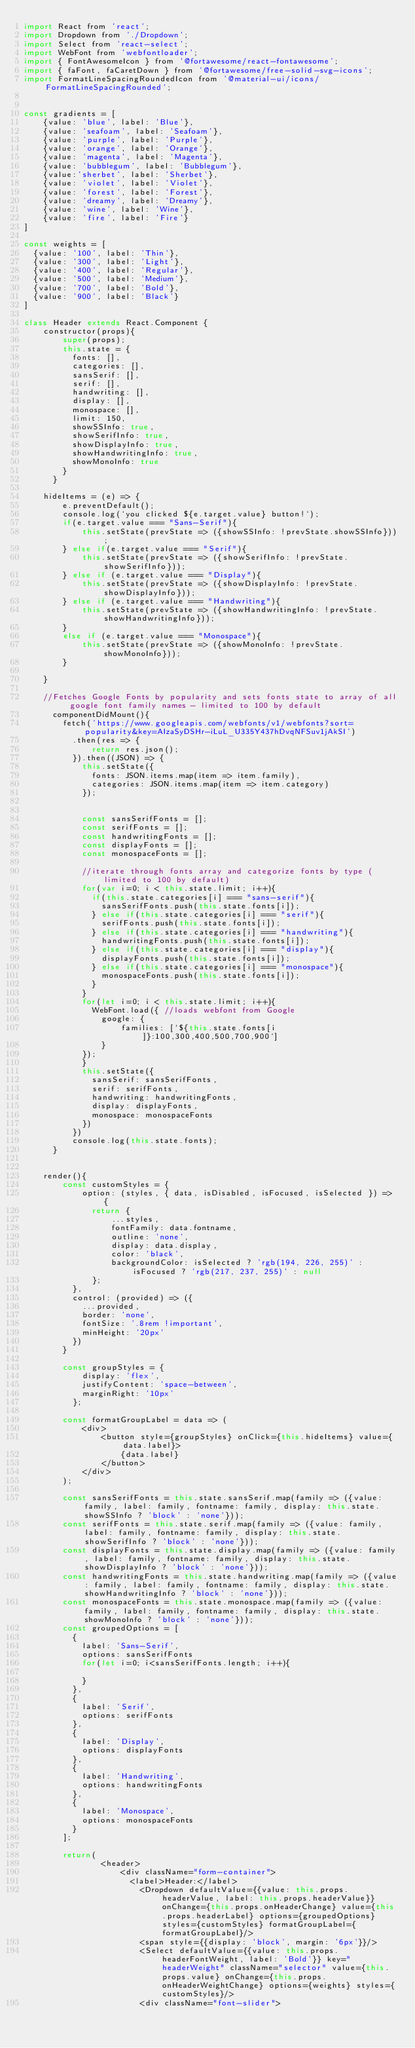Convert code to text. <code><loc_0><loc_0><loc_500><loc_500><_JavaScript_>import React from 'react';
import Dropdown from './Dropdown';
import Select from 'react-select';
import WebFont from 'webfontloader';
import { FontAwesomeIcon } from '@fortawesome/react-fontawesome';
import { faFont, faCaretDown } from '@fortawesome/free-solid-svg-icons';
import FormatLineSpacingRoundedIcon from '@material-ui/icons/FormatLineSpacingRounded';


const gradients = [
    {value: 'blue', label: 'Blue'}, 
    {value: 'seafoam', label: 'Seafoam'},
    {value: 'purple', label: 'Purple'},
    {value: 'orange', label: 'Orange'},
    {value: 'magenta', label: 'Magenta'},
    {value: 'bubblegum', label: 'Bubblegum'},
    {value:'sherbet', label: 'Sherbet'},
    {value: 'violet', label: 'Violet'},
    {value: 'forest', label: 'Forest'},
    {value: 'dreamy', label: 'Dreamy'},
    {value: 'wine', label: 'Wine'},
    {value: 'fire', label: 'Fire'}
]

const weights = [
  {value: '100', label: 'Thin'},
  {value: '300', label: 'Light'},
  {value: '400', label: 'Regular'},
  {value: '500', label: 'Medium'},
  {value: '700', label: 'Bold'},
  {value: '900', label: 'Black'}
]

class Header extends React.Component {
    constructor(props){
        super(props);
        this.state = {
          fonts: [],
          categories: [],
          sansSerif: [],
          serif: [],
          handwriting: [],
          display: [],
          monospace: [],
          limit: 150,
          showSSInfo: true,
          showSerifInfo: true,
          showDisplayInfo: true,
          showHandwritingInfo: true,
          showMonoInfo: true
        }
      }
      
    hideItems = (e) => {
        e.preventDefault();
        console.log(`you clicked ${e.target.value} button!`);
        if(e.target.value === "Sans-Serif"){
            this.setState(prevState => ({showSSInfo: !prevState.showSSInfo}));
        } else if(e.target.value === "Serif"){
            this.setState(prevState => ({showSerifInfo: !prevState.showSerifInfo}));
        } else if (e.target.value === "Display"){
            this.setState(prevState => ({showDisplayInfo: !prevState.showDisplayInfo}));
        } else if (e.target.value === "Handwriting"){
            this.setState(prevState => ({showHandwritingInfo: !prevState.showHandwritingInfo}));
        }
        else if (e.target.value === "Monospace"){
            this.setState(prevState => ({showMonoInfo: !prevState.showMonoInfo}));
        }
        
    }
    
    //Fetches Google Fonts by popularity and sets fonts state to array of all google font family names - limited to 100 by default
      componentDidMount(){
        fetch('https://www.googleapis.com/webfonts/v1/webfonts?sort=popularity&key=AIzaSyDSHr-iLuL_U335Y437hDvqNFSuv1jAkSI')
          .then(res => {
              return res.json();
          }).then((JSON) => {
            this.setState({
              fonts: JSON.items.map(item => item.family),
              categories: JSON.items.map(item => item.category)
            });
    
            
            const sansSerifFonts = [];
            const serifFonts = [];
            const handwritingFonts = [];
            const displayFonts = [];
            const monospaceFonts = [];
    
            //iterate through fonts array and categorize fonts by type (limited to 100 by default)
            for(var i=0; i < this.state.limit; i++){
              if(this.state.categories[i] === "sans-serif"){
                sansSerifFonts.push(this.state.fonts[i]);
              } else if(this.state.categories[i] === "serif"){
                serifFonts.push(this.state.fonts[i]);
              } else if(this.state.categories[i] === "handwriting"){
                handwritingFonts.push(this.state.fonts[i]);
              } else if(this.state.categories[i] === "display"){
                displayFonts.push(this.state.fonts[i]);
              } else if(this.state.categories[i] === "monospace"){
                monospaceFonts.push(this.state.fonts[i]);
              }
            }
            for(let i=0; i < this.state.limit; i++){
              WebFont.load({ //loads webfont from Google 
                google: {
                    families: [`${this.state.fonts[i]}:100,300,400,500,700,900`]
                }
            });
            }
            this.setState({
              sansSerif: sansSerifFonts,
              serif: serifFonts,
              handwriting: handwritingFonts,
              display: displayFonts,
              monospace: monospaceFonts
            })
          })
          console.log(this.state.fonts);
      }


    render(){
        const customStyles = {
            option: (styles, { data, isDisabled, isFocused, isSelected }) => {
              return {
                  ...styles,
                  fontFamily: data.fontname,
                  outline: 'none',
                  display: data.display,
                  color: 'black',
                  backgroundColor: isSelected ? 'rgb(194, 226, 255)' :isFocused ? 'rgb(217, 237, 255)' : null
              };
          },
          control: (provided) => ({
            ...provided,
            border: 'none',
            fontSize: '.8rem !important',
            minHeight: '20px'
          })
        }

        const groupStyles = {
            display: 'flex',
            justifyContent: 'space-between',
            marginRight: '10px'
          };

        const formatGroupLabel = data => (
            <div>  
                <button style={groupStyles} onClick={this.hideItems} value={data.label}>
                    {data.label}
                </button>
            </div>
        );

        const sansSerifFonts = this.state.sansSerif.map(family => ({value: family, label: family, fontname: family, display: this.state.showSSInfo ? 'block' : 'none'}));
        const serifFonts = this.state.serif.map(family => ({value: family, label: family, fontname: family, display: this.state.showSerifInfo ? 'block' : 'none'}));
        const displayFonts = this.state.display.map(family => ({value: family, label: family, fontname: family, display: this.state.showDisplayInfo ? 'block' : 'none'}));
        const handwritingFonts = this.state.handwriting.map(family => ({value: family, label: family, fontname: family, display: this.state.showHandwritingInfo ? 'block' : 'none'}));
        const monospaceFonts = this.state.monospace.map(family => ({value: family, label: family, fontname: family, display: this.state.showMonoInfo ? 'block' : 'none'}));
        const groupedOptions = [
          {
            label: 'Sans-Serif',
            options: sansSerifFonts
            for(let i=0; i<sansSerifFonts.length; i++){
              
            }
          },
          {
            label: 'Serif',
            options: serifFonts
          },
          {
            label: 'Display',
            options: displayFonts
          },
          {
            label: 'Handwriting',
            options: handwritingFonts
          },
          {
            label: 'Monospace',
            options: monospaceFonts
          }
        ];
        
        return(
                <header>
                    <div className="form-container">
                      <label>Header:</label>
                        <Dropdown defaultValue={{value: this.props.headerValue, label: this.props.headerValue}}  onChange={this.props.onHeaderChange} value={this.props.headerLabel} options={groupedOptions} styles={customStyles} formatGroupLabel={formatGroupLabel}/>
                        <span style={{display: 'block', margin: '6px'}}/>
                        <Select defaultValue={{value: this.props.headerFontWeight, label: 'Bold'}} key="headerWeight" className="selector" value={this.props.value} onChange={this.props.onHeaderWeightChange} options={weights} styles={customStyles}/>
                        <div className="font-slider"></code> 